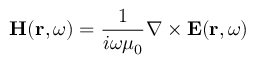Convert formula to latex. <formula><loc_0><loc_0><loc_500><loc_500>H ( r , \omega ) = \frac { 1 } { i \omega \mu _ { 0 } } \nabla \times E ( r , \omega )</formula> 